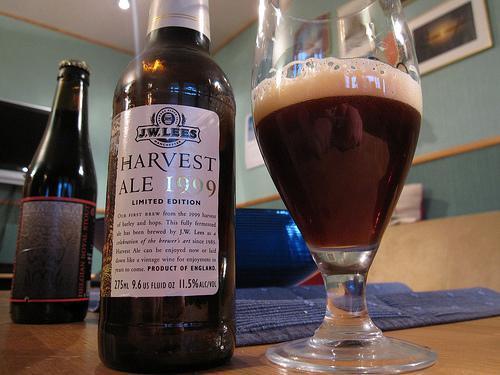How many bottles are there?
Give a very brief answer. 2. 